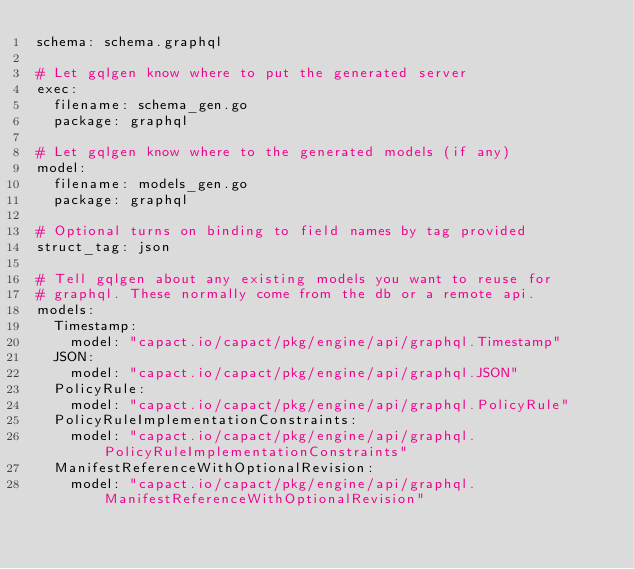Convert code to text. <code><loc_0><loc_0><loc_500><loc_500><_YAML_>schema: schema.graphql

# Let gqlgen know where to put the generated server
exec:
  filename: schema_gen.go
  package: graphql

# Let gqlgen know where to the generated models (if any)
model:
  filename: models_gen.go
  package: graphql

# Optional turns on binding to field names by tag provided
struct_tag: json

# Tell gqlgen about any existing models you want to reuse for
# graphql. These normally come from the db or a remote api.
models:
  Timestamp:
    model: "capact.io/capact/pkg/engine/api/graphql.Timestamp"
  JSON:
    model: "capact.io/capact/pkg/engine/api/graphql.JSON"
  PolicyRule:
    model: "capact.io/capact/pkg/engine/api/graphql.PolicyRule"
  PolicyRuleImplementationConstraints:
    model: "capact.io/capact/pkg/engine/api/graphql.PolicyRuleImplementationConstraints"
  ManifestReferenceWithOptionalRevision:
    model: "capact.io/capact/pkg/engine/api/graphql.ManifestReferenceWithOptionalRevision"

</code> 